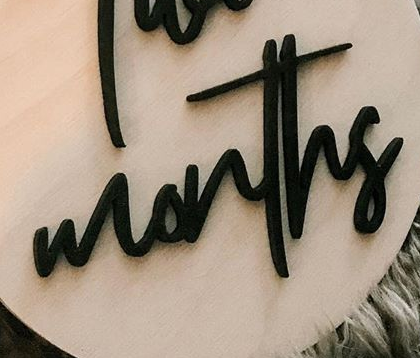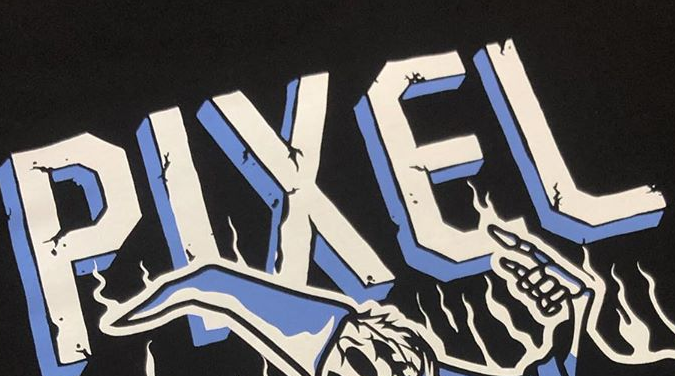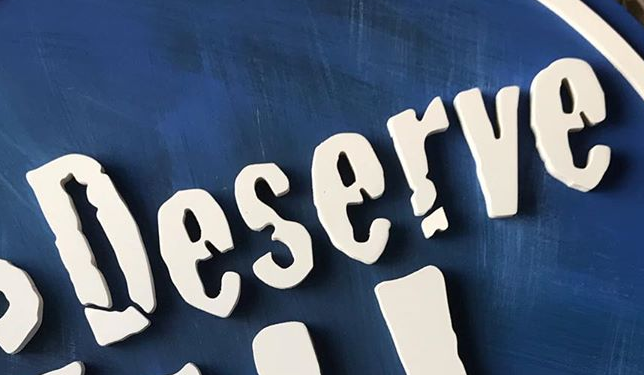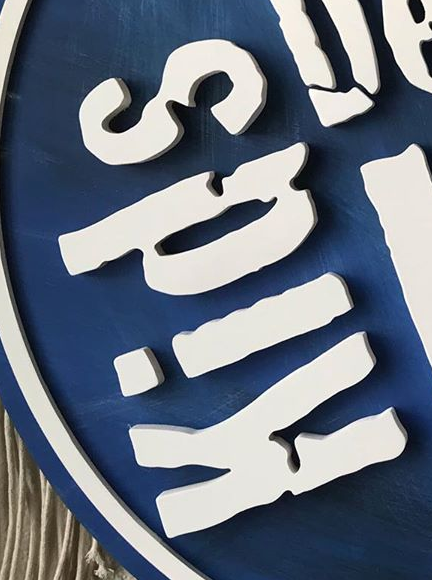What words are shown in these images in order, separated by a semicolon? months; PIXEL; Deserve; Kids 